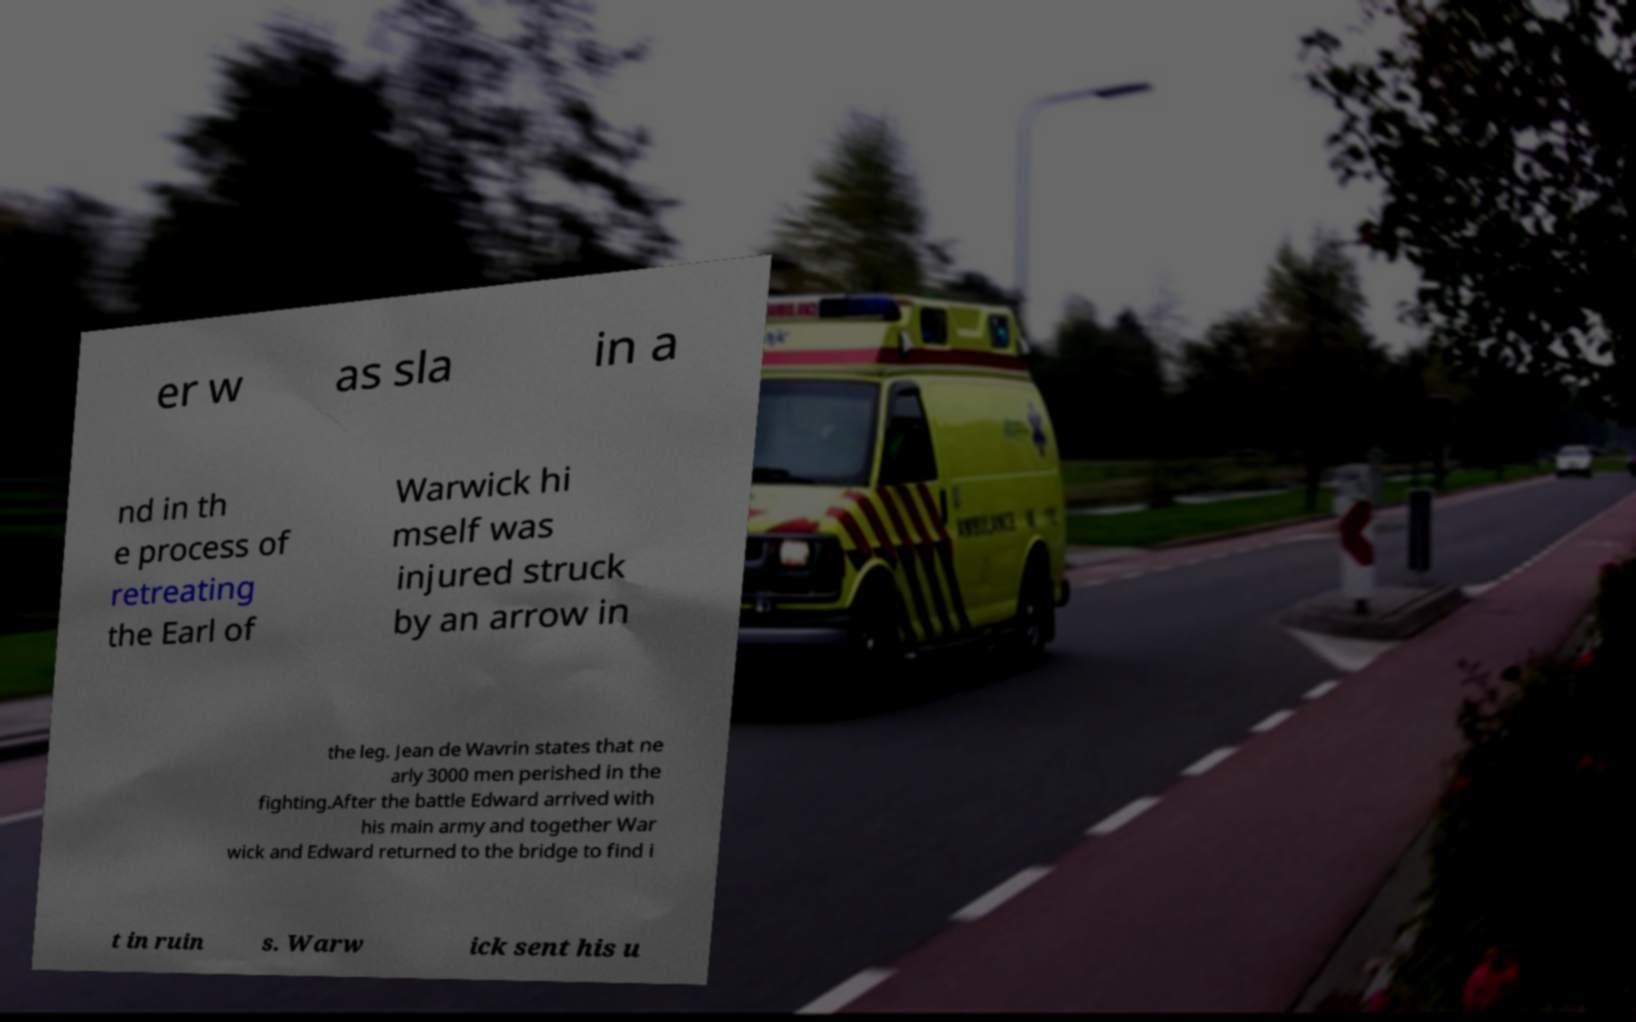Could you assist in decoding the text presented in this image and type it out clearly? er w as sla in a nd in th e process of retreating the Earl of Warwick hi mself was injured struck by an arrow in the leg. Jean de Wavrin states that ne arly 3000 men perished in the fighting.After the battle Edward arrived with his main army and together War wick and Edward returned to the bridge to find i t in ruin s. Warw ick sent his u 